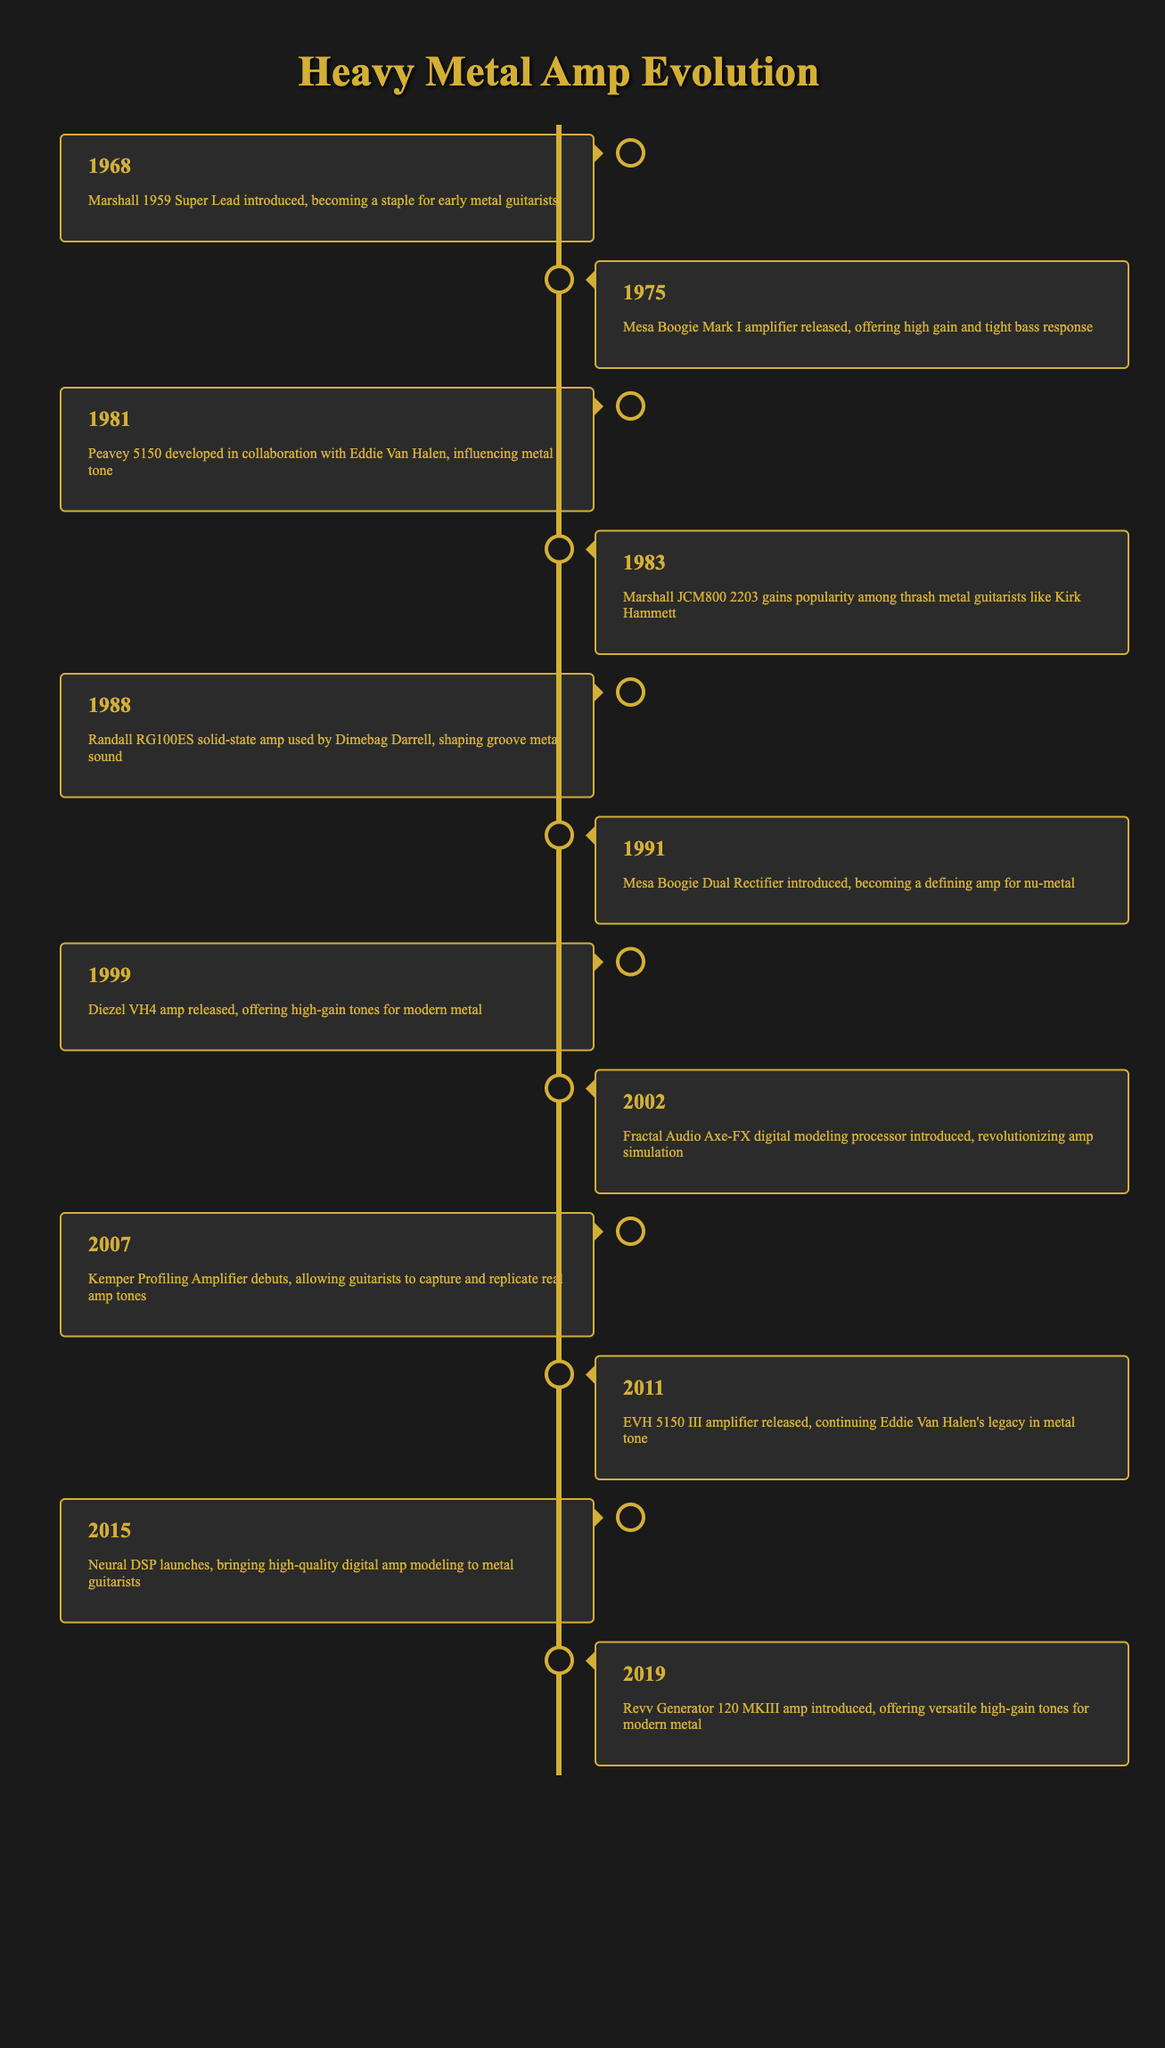What amplifier was released in 1981? The table lists the event that occurred in 1981 as the development of the Peavey 5150 amplifier, which was done in collaboration with Eddie Van Halen.
Answer: Peavey 5150 Which amplifier is known for its impact on nu-metal? The timeline indicates that the Mesa Boogie Dual Rectifier was introduced in 1991 and is described as becoming a defining amp for nu-metal.
Answer: Mesa Boogie Dual Rectifier How many years apart were the Marshall JCM800 2203 and the Diezel VH4 amplifier releases? The Marshall JCM800 2203 was introduced in 1983 and the Diezel VH4 was released in 1999. The difference in years is 1999 - 1983, which equals 16 years.
Answer: 16 years Is the first amplifier listed from the 1980s? The first amplifier listed is the Marshall 1959 Super Lead introduced in 1968, which is prior to the 1980s. Therefore, this statement is false.
Answer: No What is the trend of amplifier technology advancements from the 1960s to the 2010s? The timeline reflects a chronological progression showing advancements from the Marshall 1959 Super Lead in 1968, leading to various introducings of different amplifiers through the decades, ultimately culminating in the development of digital modeling processors such as the Fractal Audio Axe-FX in 2002, followed by the Kemper Profiling Amplifier in 2007 and modern digital models like Neural DSP in 2015. This shows a shift from traditional analog amplifiers to digital modeling and profiling technologies.
Answer: Progression from analog to digital modeling technology 